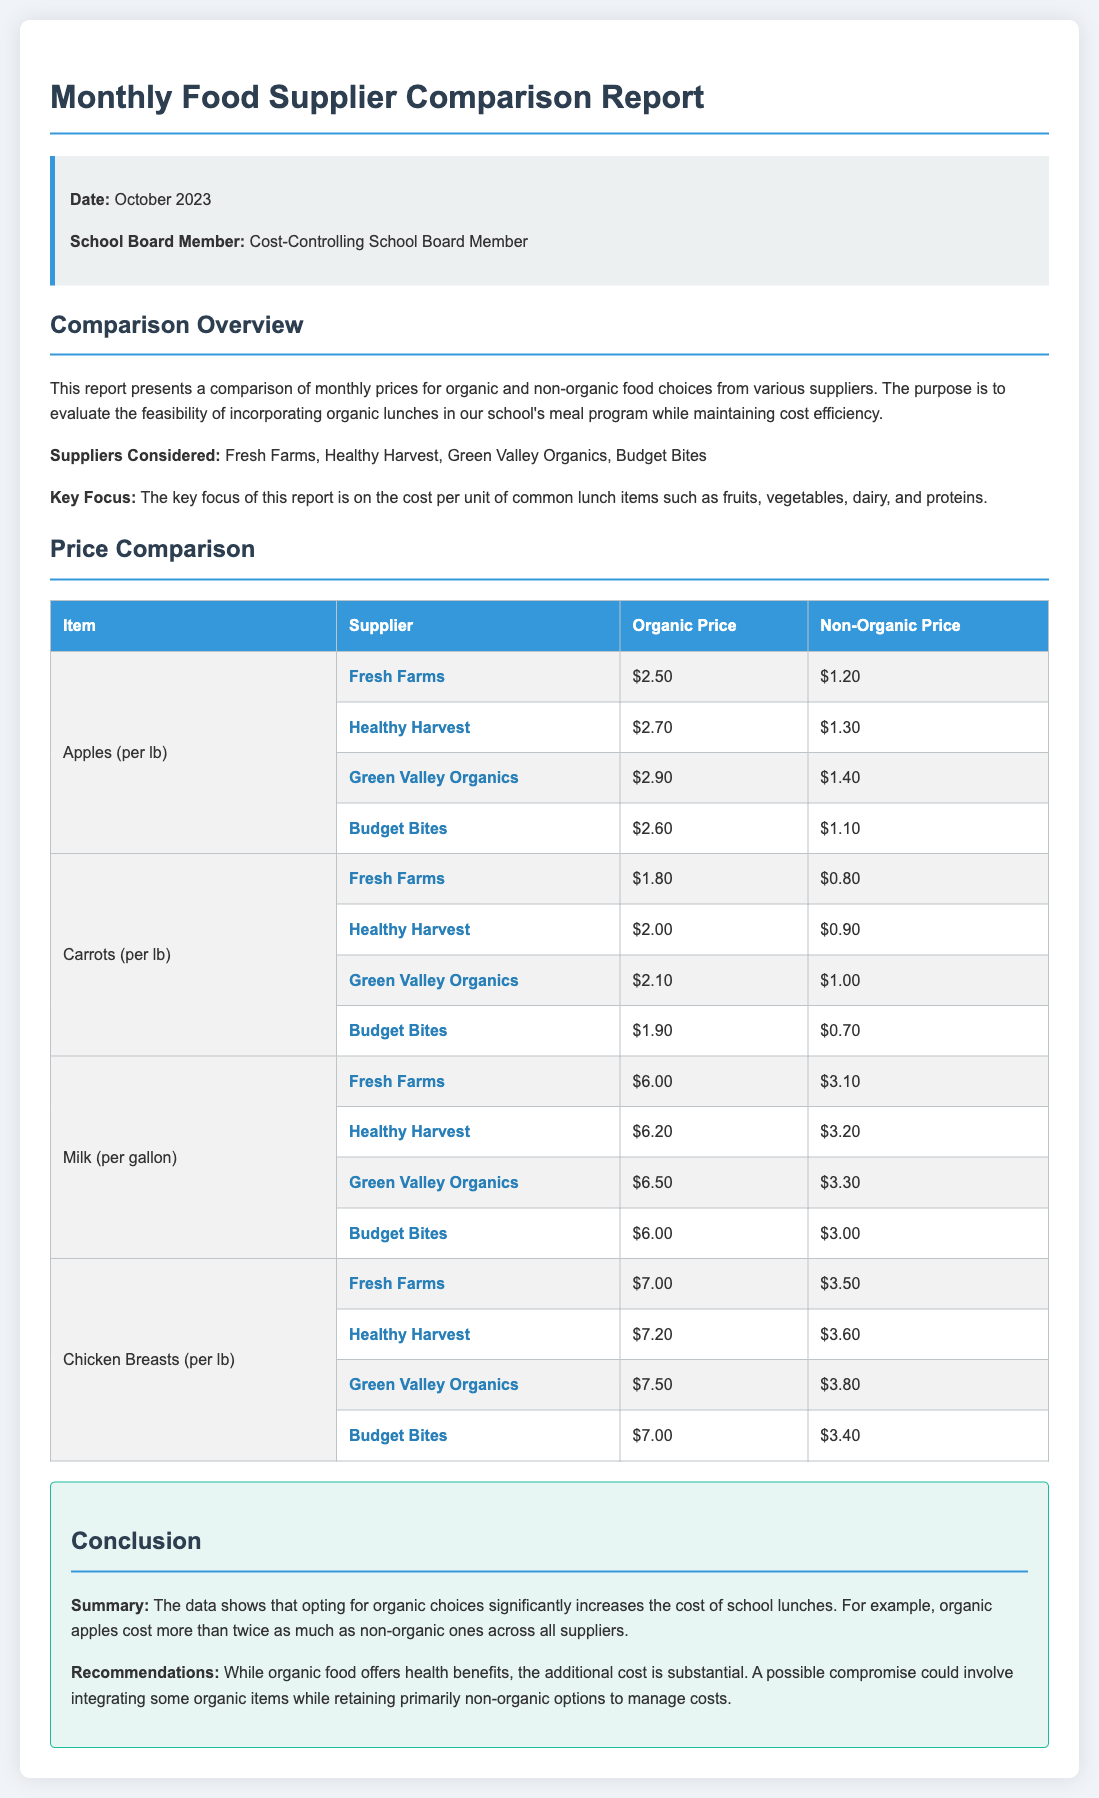What is the date of the report? The date of the report is mentioned at the top of the document.
Answer: October 2023 Who is the school board member? The name of the school board member is stated in the report information section.
Answer: Cost-Controlling School Board Member What item has the highest organic price? By analyzing the price comparison, you can see which item has the highest listed organic price among the options.
Answer: Chicken Breasts What is the organic price for carrots from Budget Bites? The specific price for carrots from Budget Bites is listed in the price comparison table.
Answer: $1.90 Which supplier offers the lowest non-organic price for apples? The comparison table indicates which supplier has the least expensive non-organic apples.
Answer: Budget Bites What is the organic price for milk from Healthy Harvest? The price comparison table provides the organic milk price from Healthy Harvest.
Answer: $6.20 What is the main concern of the report? The document states the main focus of the report in the overview section describing its purpose.
Answer: Cost efficiency What is recommended in the conclusion regarding organic choices? The conclusion section gives advice related to incorporating organic items in the meal program.
Answer: Integrating some organic items Which supplier has the highest non-organic price for chicken breasts? The non-organic price comparison shows which supplier charges the highest for chicken breasts.
Answer: Green Valley Organics 